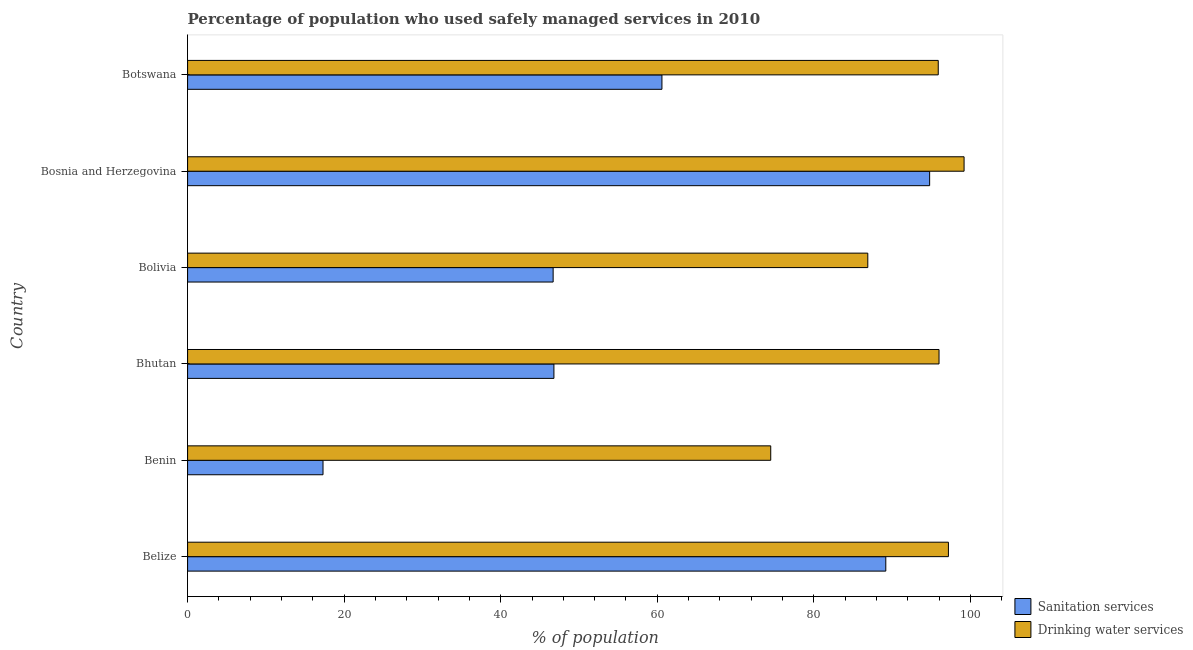How many different coloured bars are there?
Provide a short and direct response. 2. How many groups of bars are there?
Keep it short and to the point. 6. In how many cases, is the number of bars for a given country not equal to the number of legend labels?
Give a very brief answer. 0. What is the percentage of population who used drinking water services in Bolivia?
Provide a succinct answer. 86.9. Across all countries, what is the maximum percentage of population who used drinking water services?
Offer a terse response. 99.2. Across all countries, what is the minimum percentage of population who used drinking water services?
Ensure brevity in your answer.  74.5. In which country was the percentage of population who used sanitation services maximum?
Make the answer very short. Bosnia and Herzegovina. In which country was the percentage of population who used drinking water services minimum?
Offer a very short reply. Benin. What is the total percentage of population who used drinking water services in the graph?
Your answer should be compact. 549.7. What is the difference between the percentage of population who used sanitation services in Bosnia and Herzegovina and the percentage of population who used drinking water services in Bolivia?
Make the answer very short. 7.9. What is the average percentage of population who used sanitation services per country?
Provide a short and direct response. 59.23. What is the difference between the percentage of population who used drinking water services and percentage of population who used sanitation services in Belize?
Offer a very short reply. 8. What is the ratio of the percentage of population who used drinking water services in Bolivia to that in Botswana?
Make the answer very short. 0.91. Is the percentage of population who used drinking water services in Bhutan less than that in Botswana?
Your answer should be compact. No. Is the difference between the percentage of population who used sanitation services in Bhutan and Botswana greater than the difference between the percentage of population who used drinking water services in Bhutan and Botswana?
Your answer should be very brief. No. What is the difference between the highest and the lowest percentage of population who used drinking water services?
Offer a very short reply. 24.7. In how many countries, is the percentage of population who used sanitation services greater than the average percentage of population who used sanitation services taken over all countries?
Offer a terse response. 3. What does the 1st bar from the top in Bosnia and Herzegovina represents?
Your answer should be very brief. Drinking water services. What does the 2nd bar from the bottom in Belize represents?
Provide a succinct answer. Drinking water services. How many bars are there?
Your response must be concise. 12. How many countries are there in the graph?
Your response must be concise. 6. Does the graph contain any zero values?
Your answer should be very brief. No. Does the graph contain grids?
Ensure brevity in your answer.  No. Where does the legend appear in the graph?
Make the answer very short. Bottom right. How many legend labels are there?
Offer a terse response. 2. What is the title of the graph?
Your answer should be very brief. Percentage of population who used safely managed services in 2010. Does "Quasi money growth" appear as one of the legend labels in the graph?
Your answer should be compact. No. What is the label or title of the X-axis?
Keep it short and to the point. % of population. What is the label or title of the Y-axis?
Offer a terse response. Country. What is the % of population in Sanitation services in Belize?
Your answer should be very brief. 89.2. What is the % of population of Drinking water services in Belize?
Give a very brief answer. 97.2. What is the % of population of Drinking water services in Benin?
Your answer should be compact. 74.5. What is the % of population of Sanitation services in Bhutan?
Give a very brief answer. 46.8. What is the % of population of Drinking water services in Bhutan?
Your answer should be compact. 96. What is the % of population of Sanitation services in Bolivia?
Make the answer very short. 46.7. What is the % of population of Drinking water services in Bolivia?
Your response must be concise. 86.9. What is the % of population in Sanitation services in Bosnia and Herzegovina?
Your response must be concise. 94.8. What is the % of population in Drinking water services in Bosnia and Herzegovina?
Make the answer very short. 99.2. What is the % of population in Sanitation services in Botswana?
Provide a short and direct response. 60.6. What is the % of population of Drinking water services in Botswana?
Your answer should be compact. 95.9. Across all countries, what is the maximum % of population of Sanitation services?
Offer a terse response. 94.8. Across all countries, what is the maximum % of population of Drinking water services?
Offer a very short reply. 99.2. Across all countries, what is the minimum % of population in Sanitation services?
Offer a terse response. 17.3. Across all countries, what is the minimum % of population of Drinking water services?
Offer a terse response. 74.5. What is the total % of population in Sanitation services in the graph?
Ensure brevity in your answer.  355.4. What is the total % of population of Drinking water services in the graph?
Offer a very short reply. 549.7. What is the difference between the % of population of Sanitation services in Belize and that in Benin?
Offer a terse response. 71.9. What is the difference between the % of population in Drinking water services in Belize and that in Benin?
Your answer should be very brief. 22.7. What is the difference between the % of population of Sanitation services in Belize and that in Bhutan?
Keep it short and to the point. 42.4. What is the difference between the % of population in Sanitation services in Belize and that in Bolivia?
Your answer should be very brief. 42.5. What is the difference between the % of population in Drinking water services in Belize and that in Bosnia and Herzegovina?
Your answer should be very brief. -2. What is the difference between the % of population in Sanitation services in Belize and that in Botswana?
Offer a very short reply. 28.6. What is the difference between the % of population of Sanitation services in Benin and that in Bhutan?
Give a very brief answer. -29.5. What is the difference between the % of population in Drinking water services in Benin and that in Bhutan?
Your response must be concise. -21.5. What is the difference between the % of population of Sanitation services in Benin and that in Bolivia?
Your answer should be compact. -29.4. What is the difference between the % of population in Drinking water services in Benin and that in Bolivia?
Keep it short and to the point. -12.4. What is the difference between the % of population in Sanitation services in Benin and that in Bosnia and Herzegovina?
Your response must be concise. -77.5. What is the difference between the % of population in Drinking water services in Benin and that in Bosnia and Herzegovina?
Make the answer very short. -24.7. What is the difference between the % of population of Sanitation services in Benin and that in Botswana?
Your response must be concise. -43.3. What is the difference between the % of population of Drinking water services in Benin and that in Botswana?
Offer a very short reply. -21.4. What is the difference between the % of population in Drinking water services in Bhutan and that in Bolivia?
Your answer should be compact. 9.1. What is the difference between the % of population in Sanitation services in Bhutan and that in Bosnia and Herzegovina?
Provide a short and direct response. -48. What is the difference between the % of population of Drinking water services in Bhutan and that in Bosnia and Herzegovina?
Your answer should be compact. -3.2. What is the difference between the % of population of Sanitation services in Bhutan and that in Botswana?
Ensure brevity in your answer.  -13.8. What is the difference between the % of population in Drinking water services in Bhutan and that in Botswana?
Your answer should be very brief. 0.1. What is the difference between the % of population in Sanitation services in Bolivia and that in Bosnia and Herzegovina?
Provide a short and direct response. -48.1. What is the difference between the % of population of Drinking water services in Bolivia and that in Bosnia and Herzegovina?
Give a very brief answer. -12.3. What is the difference between the % of population of Sanitation services in Bosnia and Herzegovina and that in Botswana?
Provide a succinct answer. 34.2. What is the difference between the % of population of Drinking water services in Bosnia and Herzegovina and that in Botswana?
Offer a very short reply. 3.3. What is the difference between the % of population of Sanitation services in Belize and the % of population of Drinking water services in Bolivia?
Make the answer very short. 2.3. What is the difference between the % of population of Sanitation services in Belize and the % of population of Drinking water services in Botswana?
Your answer should be compact. -6.7. What is the difference between the % of population of Sanitation services in Benin and the % of population of Drinking water services in Bhutan?
Provide a succinct answer. -78.7. What is the difference between the % of population in Sanitation services in Benin and the % of population in Drinking water services in Bolivia?
Ensure brevity in your answer.  -69.6. What is the difference between the % of population in Sanitation services in Benin and the % of population in Drinking water services in Bosnia and Herzegovina?
Keep it short and to the point. -81.9. What is the difference between the % of population of Sanitation services in Benin and the % of population of Drinking water services in Botswana?
Offer a terse response. -78.6. What is the difference between the % of population of Sanitation services in Bhutan and the % of population of Drinking water services in Bolivia?
Give a very brief answer. -40.1. What is the difference between the % of population in Sanitation services in Bhutan and the % of population in Drinking water services in Bosnia and Herzegovina?
Your answer should be very brief. -52.4. What is the difference between the % of population of Sanitation services in Bhutan and the % of population of Drinking water services in Botswana?
Provide a short and direct response. -49.1. What is the difference between the % of population in Sanitation services in Bolivia and the % of population in Drinking water services in Bosnia and Herzegovina?
Make the answer very short. -52.5. What is the difference between the % of population of Sanitation services in Bolivia and the % of population of Drinking water services in Botswana?
Keep it short and to the point. -49.2. What is the average % of population in Sanitation services per country?
Make the answer very short. 59.23. What is the average % of population of Drinking water services per country?
Your response must be concise. 91.62. What is the difference between the % of population in Sanitation services and % of population in Drinking water services in Belize?
Offer a terse response. -8. What is the difference between the % of population of Sanitation services and % of population of Drinking water services in Benin?
Give a very brief answer. -57.2. What is the difference between the % of population of Sanitation services and % of population of Drinking water services in Bhutan?
Your answer should be very brief. -49.2. What is the difference between the % of population of Sanitation services and % of population of Drinking water services in Bolivia?
Provide a short and direct response. -40.2. What is the difference between the % of population in Sanitation services and % of population in Drinking water services in Bosnia and Herzegovina?
Give a very brief answer. -4.4. What is the difference between the % of population in Sanitation services and % of population in Drinking water services in Botswana?
Your answer should be very brief. -35.3. What is the ratio of the % of population in Sanitation services in Belize to that in Benin?
Offer a very short reply. 5.16. What is the ratio of the % of population in Drinking water services in Belize to that in Benin?
Ensure brevity in your answer.  1.3. What is the ratio of the % of population of Sanitation services in Belize to that in Bhutan?
Ensure brevity in your answer.  1.91. What is the ratio of the % of population of Drinking water services in Belize to that in Bhutan?
Offer a very short reply. 1.01. What is the ratio of the % of population in Sanitation services in Belize to that in Bolivia?
Keep it short and to the point. 1.91. What is the ratio of the % of population of Drinking water services in Belize to that in Bolivia?
Your answer should be very brief. 1.12. What is the ratio of the % of population of Sanitation services in Belize to that in Bosnia and Herzegovina?
Your answer should be compact. 0.94. What is the ratio of the % of population in Drinking water services in Belize to that in Bosnia and Herzegovina?
Your response must be concise. 0.98. What is the ratio of the % of population of Sanitation services in Belize to that in Botswana?
Give a very brief answer. 1.47. What is the ratio of the % of population in Drinking water services in Belize to that in Botswana?
Ensure brevity in your answer.  1.01. What is the ratio of the % of population in Sanitation services in Benin to that in Bhutan?
Make the answer very short. 0.37. What is the ratio of the % of population in Drinking water services in Benin to that in Bhutan?
Ensure brevity in your answer.  0.78. What is the ratio of the % of population in Sanitation services in Benin to that in Bolivia?
Your answer should be compact. 0.37. What is the ratio of the % of population of Drinking water services in Benin to that in Bolivia?
Provide a short and direct response. 0.86. What is the ratio of the % of population in Sanitation services in Benin to that in Bosnia and Herzegovina?
Keep it short and to the point. 0.18. What is the ratio of the % of population in Drinking water services in Benin to that in Bosnia and Herzegovina?
Provide a short and direct response. 0.75. What is the ratio of the % of population in Sanitation services in Benin to that in Botswana?
Your answer should be compact. 0.29. What is the ratio of the % of population in Drinking water services in Benin to that in Botswana?
Offer a terse response. 0.78. What is the ratio of the % of population in Sanitation services in Bhutan to that in Bolivia?
Keep it short and to the point. 1. What is the ratio of the % of population in Drinking water services in Bhutan to that in Bolivia?
Provide a short and direct response. 1.1. What is the ratio of the % of population of Sanitation services in Bhutan to that in Bosnia and Herzegovina?
Offer a terse response. 0.49. What is the ratio of the % of population in Sanitation services in Bhutan to that in Botswana?
Ensure brevity in your answer.  0.77. What is the ratio of the % of population in Drinking water services in Bhutan to that in Botswana?
Offer a terse response. 1. What is the ratio of the % of population in Sanitation services in Bolivia to that in Bosnia and Herzegovina?
Your answer should be compact. 0.49. What is the ratio of the % of population of Drinking water services in Bolivia to that in Bosnia and Herzegovina?
Keep it short and to the point. 0.88. What is the ratio of the % of population of Sanitation services in Bolivia to that in Botswana?
Keep it short and to the point. 0.77. What is the ratio of the % of population in Drinking water services in Bolivia to that in Botswana?
Make the answer very short. 0.91. What is the ratio of the % of population in Sanitation services in Bosnia and Herzegovina to that in Botswana?
Keep it short and to the point. 1.56. What is the ratio of the % of population in Drinking water services in Bosnia and Herzegovina to that in Botswana?
Make the answer very short. 1.03. What is the difference between the highest and the second highest % of population in Sanitation services?
Give a very brief answer. 5.6. What is the difference between the highest and the second highest % of population of Drinking water services?
Keep it short and to the point. 2. What is the difference between the highest and the lowest % of population of Sanitation services?
Your response must be concise. 77.5. What is the difference between the highest and the lowest % of population in Drinking water services?
Offer a terse response. 24.7. 